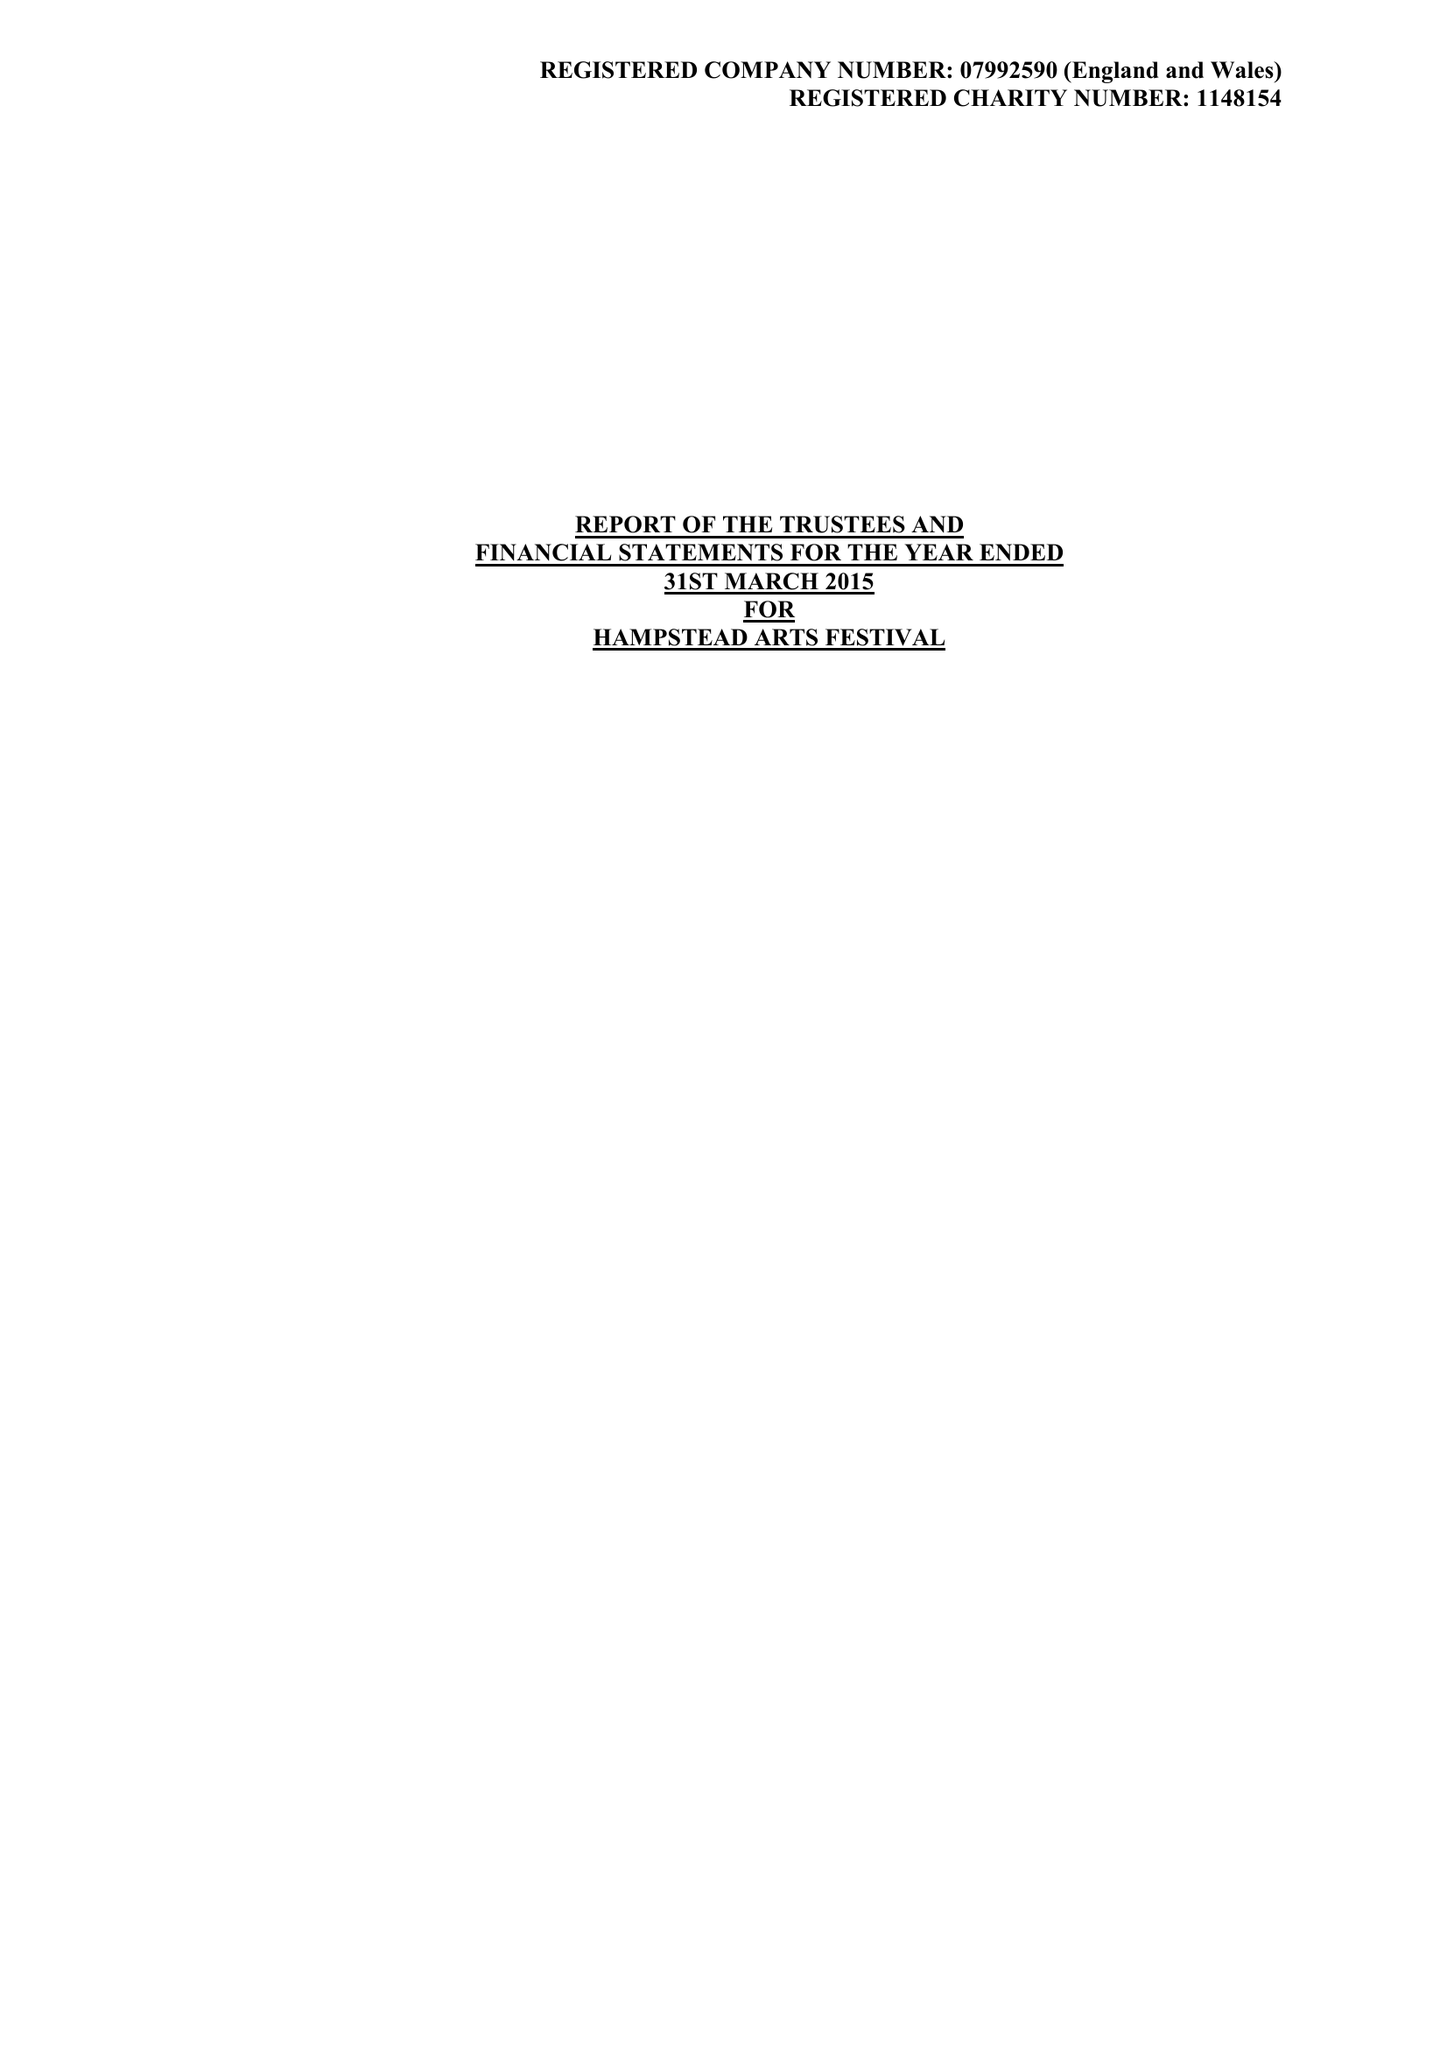What is the value for the address__street_line?
Answer the question using a single word or phrase. 31/33 COLLEGE ROAD 